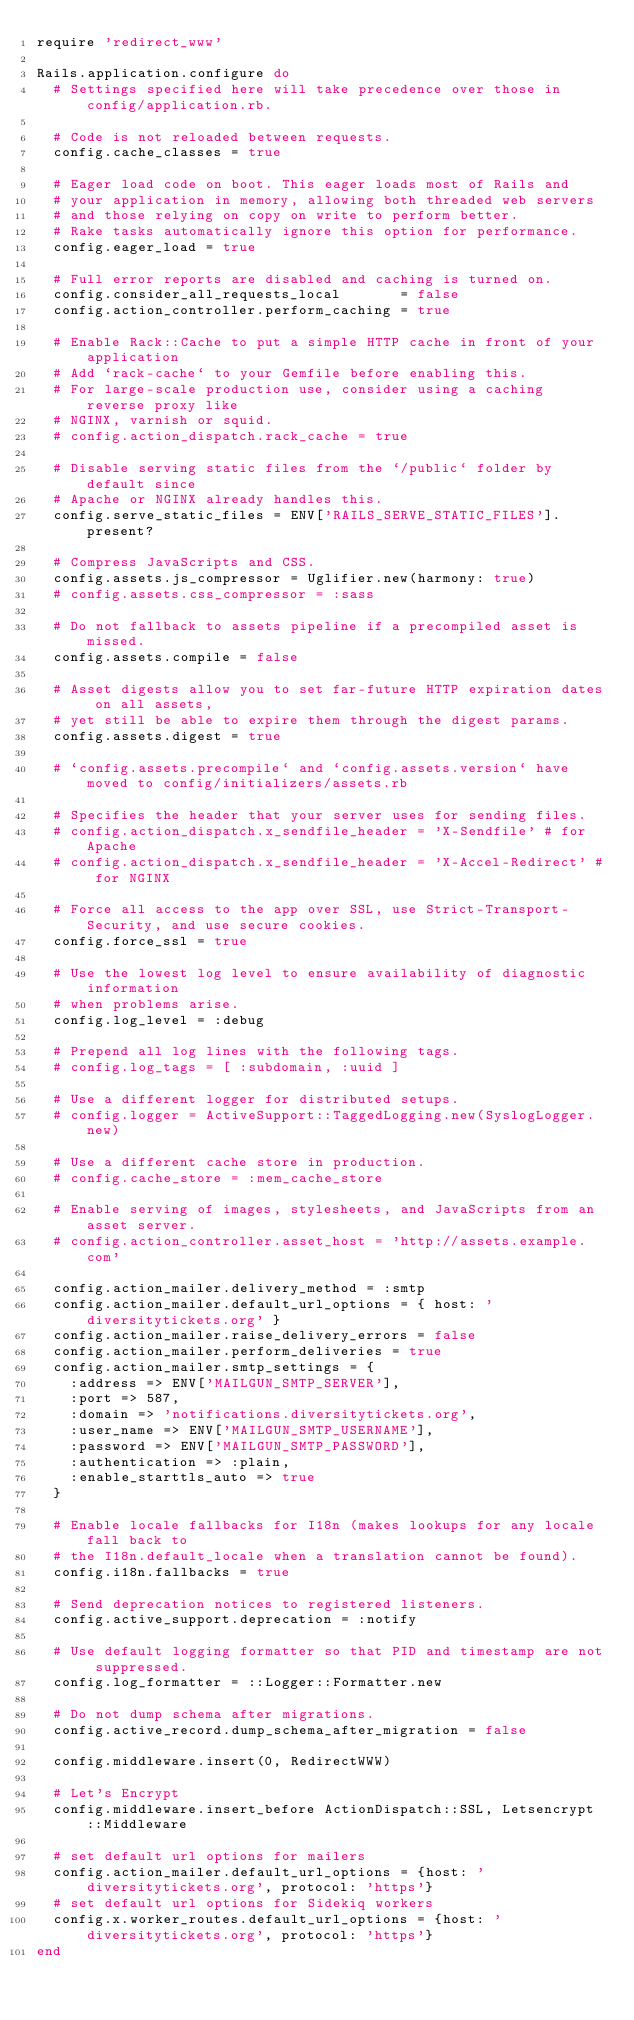Convert code to text. <code><loc_0><loc_0><loc_500><loc_500><_Ruby_>require 'redirect_www'

Rails.application.configure do
  # Settings specified here will take precedence over those in config/application.rb.

  # Code is not reloaded between requests.
  config.cache_classes = true

  # Eager load code on boot. This eager loads most of Rails and
  # your application in memory, allowing both threaded web servers
  # and those relying on copy on write to perform better.
  # Rake tasks automatically ignore this option for performance.
  config.eager_load = true

  # Full error reports are disabled and caching is turned on.
  config.consider_all_requests_local       = false
  config.action_controller.perform_caching = true

  # Enable Rack::Cache to put a simple HTTP cache in front of your application
  # Add `rack-cache` to your Gemfile before enabling this.
  # For large-scale production use, consider using a caching reverse proxy like
  # NGINX, varnish or squid.
  # config.action_dispatch.rack_cache = true

  # Disable serving static files from the `/public` folder by default since
  # Apache or NGINX already handles this.
  config.serve_static_files = ENV['RAILS_SERVE_STATIC_FILES'].present?

  # Compress JavaScripts and CSS.
  config.assets.js_compressor = Uglifier.new(harmony: true)
  # config.assets.css_compressor = :sass

  # Do not fallback to assets pipeline if a precompiled asset is missed.
  config.assets.compile = false

  # Asset digests allow you to set far-future HTTP expiration dates on all assets,
  # yet still be able to expire them through the digest params.
  config.assets.digest = true

  # `config.assets.precompile` and `config.assets.version` have moved to config/initializers/assets.rb

  # Specifies the header that your server uses for sending files.
  # config.action_dispatch.x_sendfile_header = 'X-Sendfile' # for Apache
  # config.action_dispatch.x_sendfile_header = 'X-Accel-Redirect' # for NGINX

  # Force all access to the app over SSL, use Strict-Transport-Security, and use secure cookies.
  config.force_ssl = true

  # Use the lowest log level to ensure availability of diagnostic information
  # when problems arise.
  config.log_level = :debug

  # Prepend all log lines with the following tags.
  # config.log_tags = [ :subdomain, :uuid ]

  # Use a different logger for distributed setups.
  # config.logger = ActiveSupport::TaggedLogging.new(SyslogLogger.new)

  # Use a different cache store in production.
  # config.cache_store = :mem_cache_store

  # Enable serving of images, stylesheets, and JavaScripts from an asset server.
  # config.action_controller.asset_host = 'http://assets.example.com'

  config.action_mailer.delivery_method = :smtp
  config.action_mailer.default_url_options = { host: 'diversitytickets.org' }
  config.action_mailer.raise_delivery_errors = false
  config.action_mailer.perform_deliveries = true
  config.action_mailer.smtp_settings = {
    :address => ENV['MAILGUN_SMTP_SERVER'],
    :port => 587,
    :domain => 'notifications.diversitytickets.org',
    :user_name => ENV['MAILGUN_SMTP_USERNAME'],
    :password => ENV['MAILGUN_SMTP_PASSWORD'],
    :authentication => :plain,
    :enable_starttls_auto => true
  }

  # Enable locale fallbacks for I18n (makes lookups for any locale fall back to
  # the I18n.default_locale when a translation cannot be found).
  config.i18n.fallbacks = true

  # Send deprecation notices to registered listeners.
  config.active_support.deprecation = :notify

  # Use default logging formatter so that PID and timestamp are not suppressed.
  config.log_formatter = ::Logger::Formatter.new

  # Do not dump schema after migrations.
  config.active_record.dump_schema_after_migration = false

  config.middleware.insert(0, RedirectWWW)

  # Let's Encrypt
  config.middleware.insert_before ActionDispatch::SSL, Letsencrypt::Middleware

  # set default url options for mailers
  config.action_mailer.default_url_options = {host: 'diversitytickets.org', protocol: 'https'}
  # set default url options for Sidekiq workers
  config.x.worker_routes.default_url_options = {host: 'diversitytickets.org', protocol: 'https'}
end
</code> 